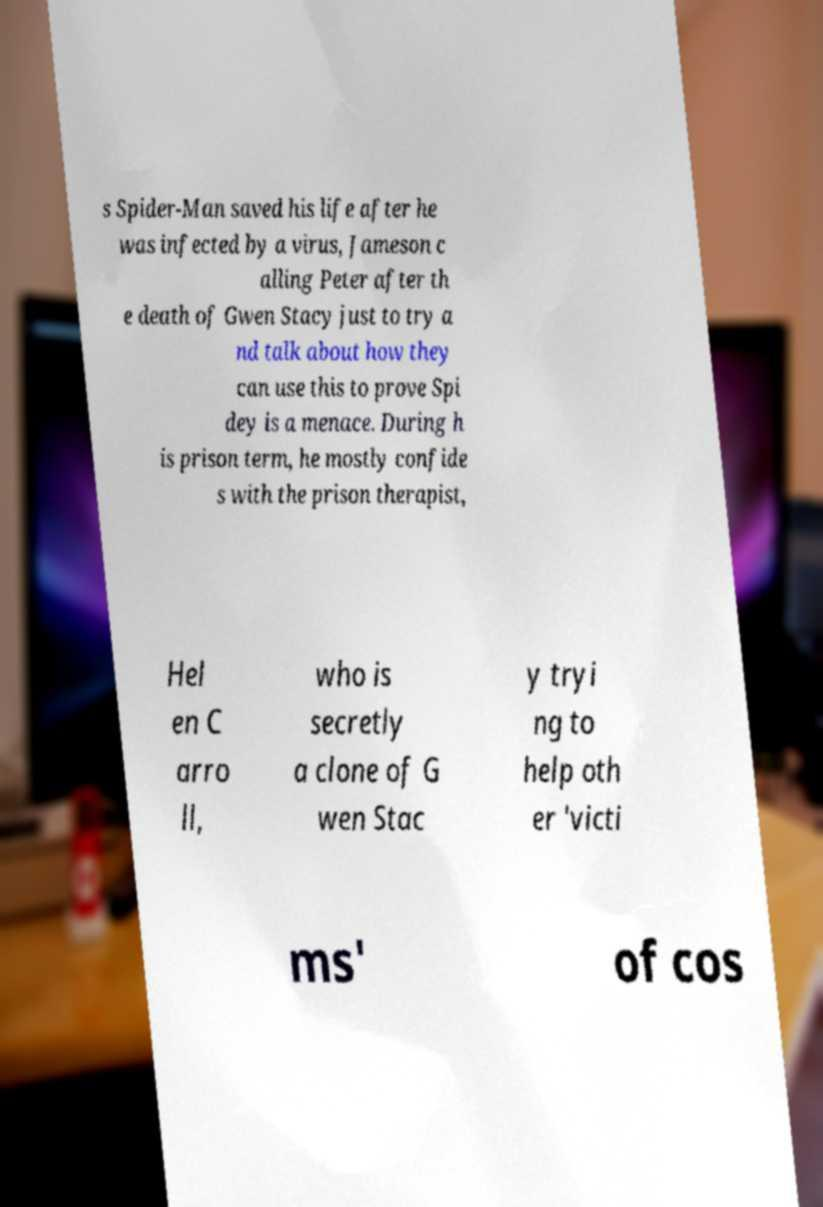I need the written content from this picture converted into text. Can you do that? s Spider-Man saved his life after he was infected by a virus, Jameson c alling Peter after th e death of Gwen Stacy just to try a nd talk about how they can use this to prove Spi dey is a menace. During h is prison term, he mostly confide s with the prison therapist, Hel en C arro ll, who is secretly a clone of G wen Stac y tryi ng to help oth er 'victi ms' of cos 